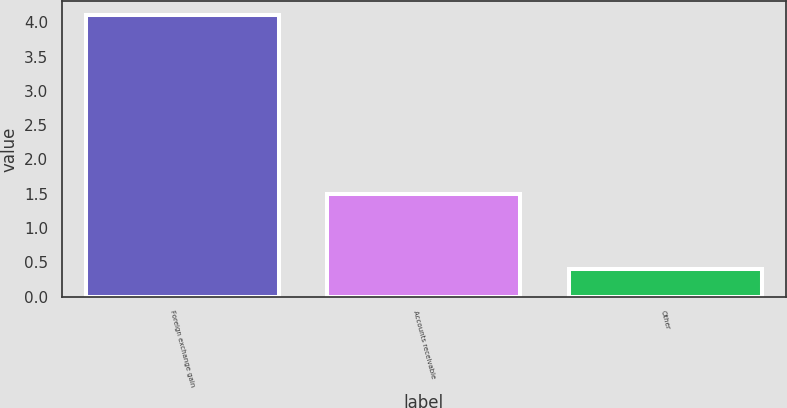Convert chart to OTSL. <chart><loc_0><loc_0><loc_500><loc_500><bar_chart><fcel>Foreign exchange gain<fcel>Accounts receivable<fcel>Other<nl><fcel>4.1<fcel>1.5<fcel>0.4<nl></chart> 